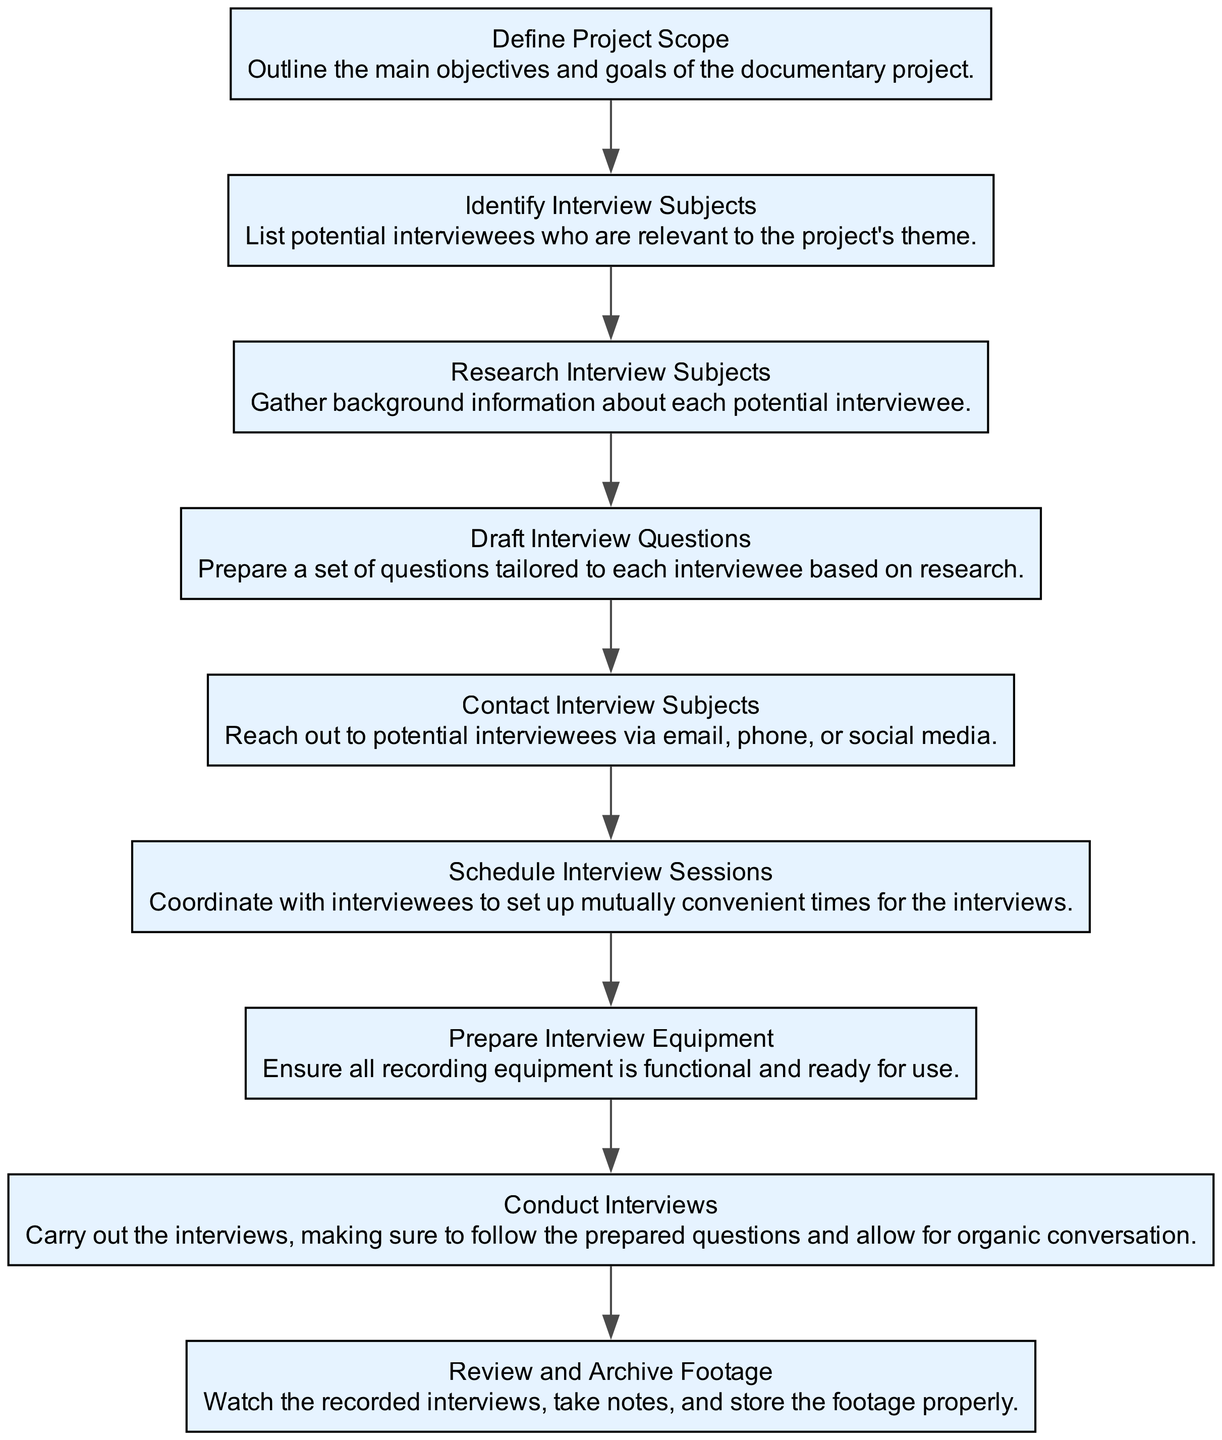What is the first step in the process? The first step is represented by the node "Define Project Scope." Since it has no dependencies, it is the starting point of the flow.
Answer: Define Project Scope How many nodes are present in the diagram? By counting all the individual steps (nodes) listed in the flow chart, a total of nine distinct steps can be identified.
Answer: Nine Which step follows "Contact Interview Subjects"? "Schedule Interview Sessions" directly follows "Contact Interview Subjects" as indicated by the directional flow connecting these two nodes sequentially.
Answer: Schedule Interview Sessions What is the last step in the process? The last step is represented by the node "Review and Archive Footage," which is the final action taken after all previous steps have been completed.
Answer: Review and Archive Footage What is required before "Conduct Interviews"? The step "Prepare Interview Equipment" must be completed before moving on to "Conduct Interviews," as indicated by the flow of dependencies leading to it.
Answer: Prepare Interview Equipment How many dependencies does "Draft Interview Questions" have? The node "Draft Interview Questions" has one dependency, which is "Research Interview Subjects," as noted in the flow chart.
Answer: One What are the steps that need to be taken before "Conduct Interviews"? To reach "Conduct Interviews," one must first complete "Prepare Interview Equipment," which follows after "Schedule Interview Sessions" and its prerequisite "Contact Interview Subjects." Therefore, the series of steps includes "Schedule Interview Sessions" and "Prepare Interview Equipment."
Answer: Schedule Interview Sessions, Prepare Interview Equipment Which step has the most dependencies? The step "Conduct Interviews" has the most dependencies, specifically requiring completion of "Prepare Interview Equipment." However, it is also contingent on preceding steps "Schedule Interview Sessions" and "Contact Interview Subjects."
Answer: Conduct Interviews What node comes immediately after "Identify Interview Subjects"? The node "Research Interview Subjects" follows directly after "Identify Interview Subjects," indicating the next action that must be taken in the flow.
Answer: Research Interview Subjects 